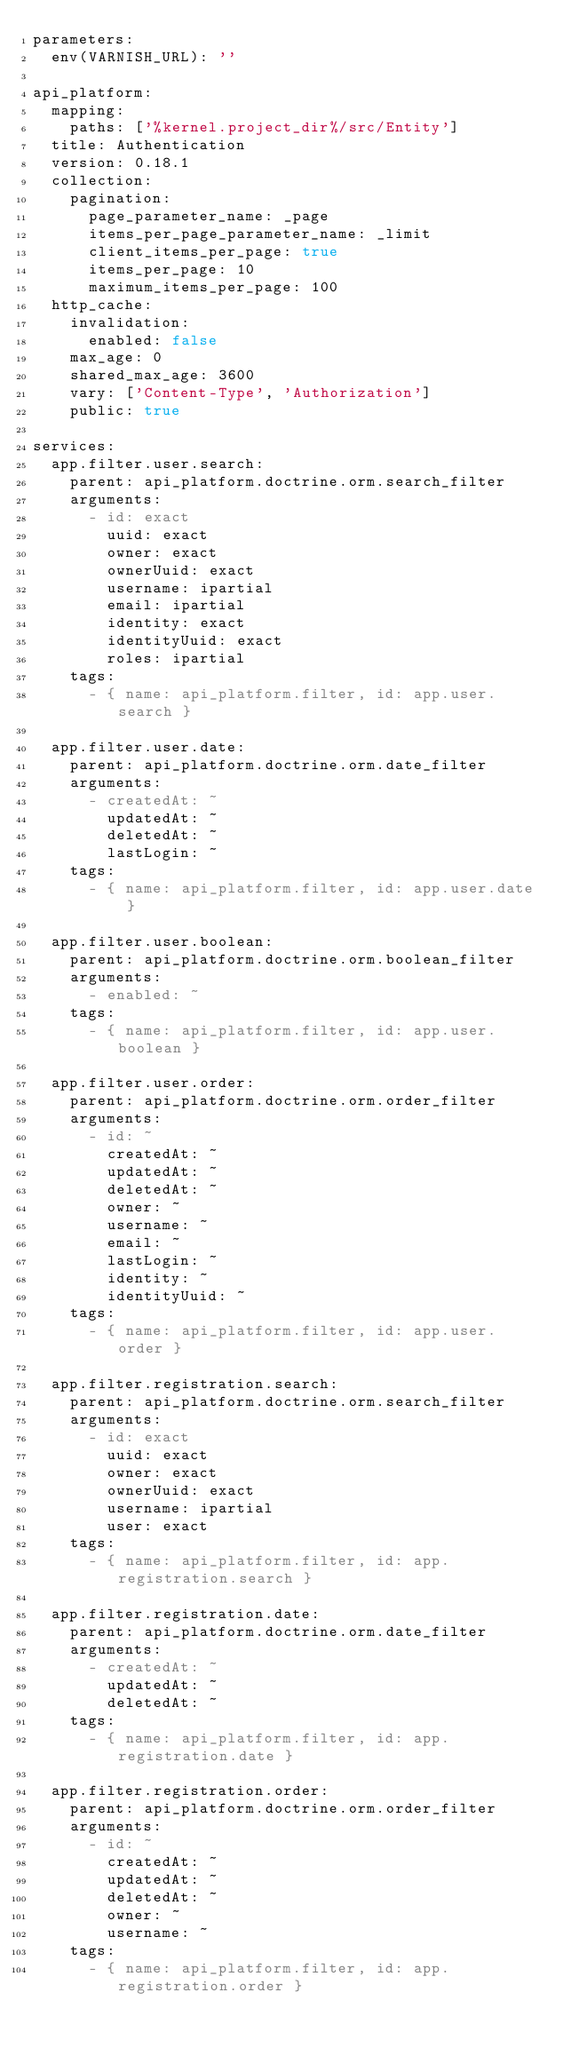Convert code to text. <code><loc_0><loc_0><loc_500><loc_500><_YAML_>parameters:
  env(VARNISH_URL): ''

api_platform:
  mapping:
    paths: ['%kernel.project_dir%/src/Entity']
  title: Authentication
  version: 0.18.1
  collection:
    pagination:
      page_parameter_name: _page
      items_per_page_parameter_name: _limit
      client_items_per_page: true
      items_per_page: 10
      maximum_items_per_page: 100
  http_cache:
    invalidation:
      enabled: false
    max_age: 0
    shared_max_age: 3600
    vary: ['Content-Type', 'Authorization']
    public: true

services:
  app.filter.user.search:
    parent: api_platform.doctrine.orm.search_filter
    arguments:
      - id: exact
        uuid: exact
        owner: exact
        ownerUuid: exact
        username: ipartial
        email: ipartial
        identity: exact
        identityUuid: exact
        roles: ipartial
    tags:
      - { name: api_platform.filter, id: app.user.search }

  app.filter.user.date:
    parent: api_platform.doctrine.orm.date_filter
    arguments:
      - createdAt: ~
        updatedAt: ~
        deletedAt: ~
        lastLogin: ~
    tags:
      - { name: api_platform.filter, id: app.user.date }

  app.filter.user.boolean:
    parent: api_platform.doctrine.orm.boolean_filter
    arguments:
      - enabled: ~
    tags:
      - { name: api_platform.filter, id: app.user.boolean }

  app.filter.user.order:
    parent: api_platform.doctrine.orm.order_filter
    arguments:
      - id: ~
        createdAt: ~
        updatedAt: ~
        deletedAt: ~
        owner: ~
        username: ~
        email: ~
        lastLogin: ~
        identity: ~
        identityUuid: ~
    tags:
      - { name: api_platform.filter, id: app.user.order }

  app.filter.registration.search:
    parent: api_platform.doctrine.orm.search_filter
    arguments:
      - id: exact
        uuid: exact
        owner: exact
        ownerUuid: exact
        username: ipartial
        user: exact
    tags:
      - { name: api_platform.filter, id: app.registration.search }

  app.filter.registration.date:
    parent: api_platform.doctrine.orm.date_filter
    arguments:
      - createdAt: ~
        updatedAt: ~
        deletedAt: ~
    tags:
      - { name: api_platform.filter, id: app.registration.date }

  app.filter.registration.order:
    parent: api_platform.doctrine.orm.order_filter
    arguments:
      - id: ~
        createdAt: ~
        updatedAt: ~
        deletedAt: ~
        owner: ~
        username: ~
    tags:
      - { name: api_platform.filter, id: app.registration.order }
</code> 